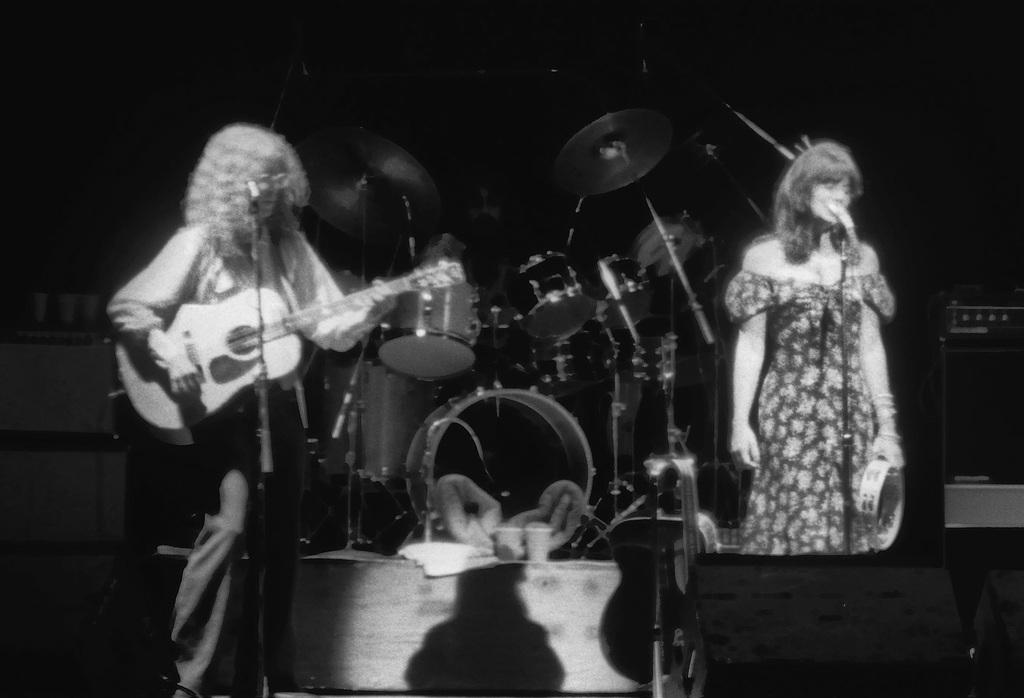What are the people in the image doing? The people in the image are standing. What instrument is one person holding? One person is holding a guitar. What equipment is visible in the background? There are microphones and a drum set in the background. How many girls are holding flags in the image? There are no girls or flags present in the image. 